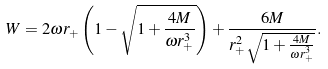<formula> <loc_0><loc_0><loc_500><loc_500>W = 2 \omega r _ { + } \left ( 1 - \sqrt { 1 + \frac { 4 M } { \omega r _ { + } ^ { 3 } } } \right ) + \frac { 6 M } { r _ { + } ^ { 2 } \sqrt { 1 + \frac { 4 M } { \omega r _ { + } ^ { 3 } } } } .</formula> 